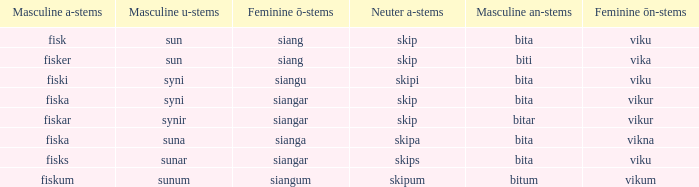What is the masculine an form for the word with a feminine ö ending of siangar and a masculine u ending of sunar? Bita. 